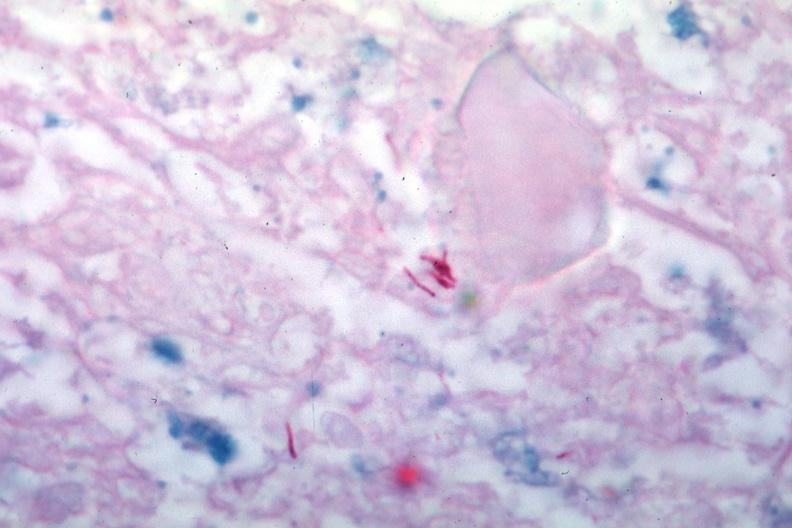s lymph node present?
Answer the question using a single word or phrase. Yes 